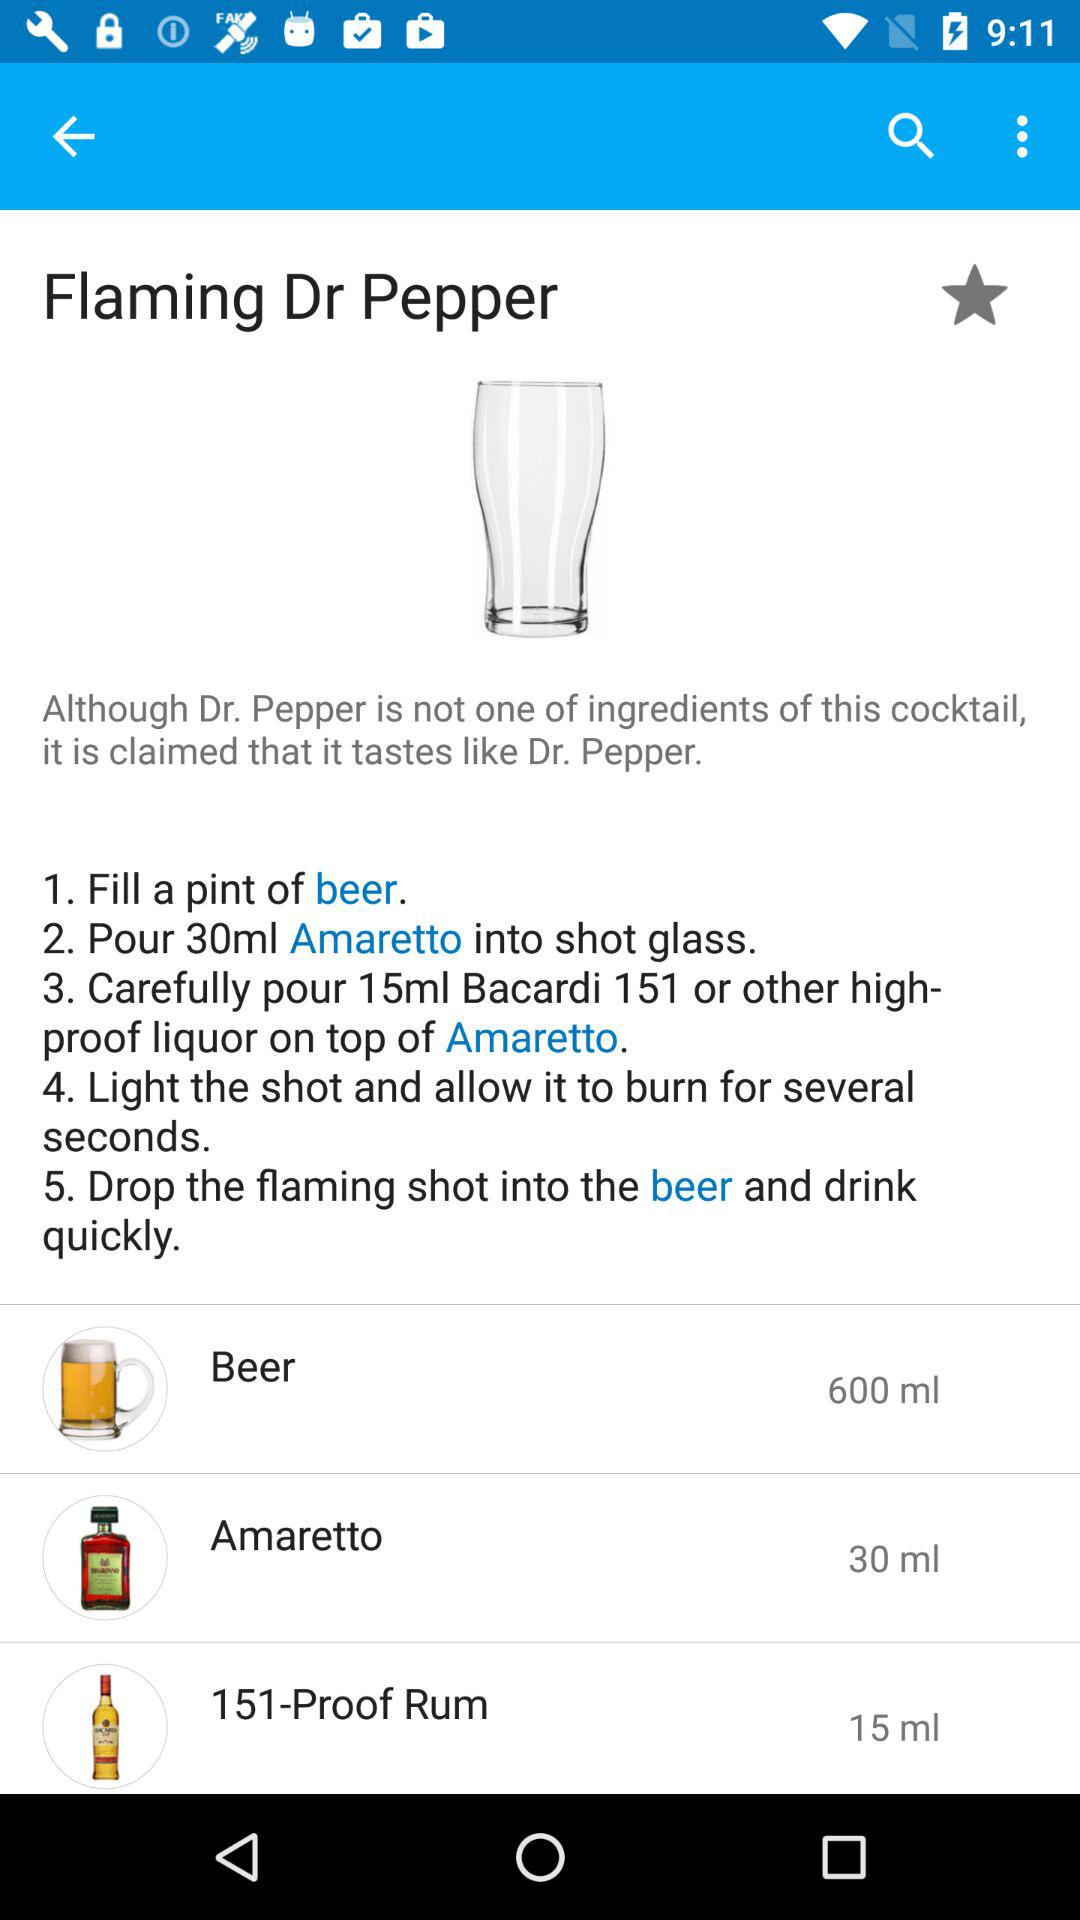How many milliliters of Amaretto are needed to make this drink?
Answer the question using a single word or phrase. 30 ml 